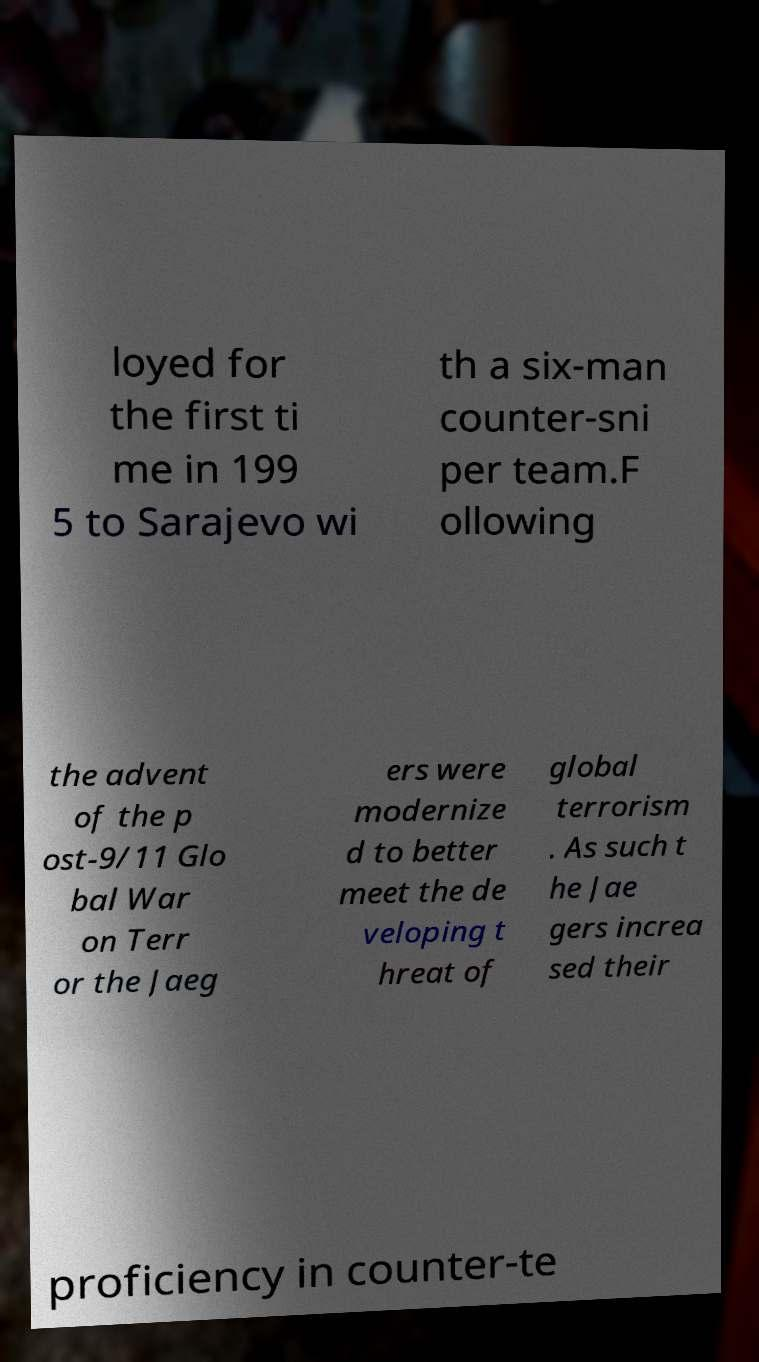There's text embedded in this image that I need extracted. Can you transcribe it verbatim? loyed for the first ti me in 199 5 to Sarajevo wi th a six-man counter-sni per team.F ollowing the advent of the p ost-9/11 Glo bal War on Terr or the Jaeg ers were modernize d to better meet the de veloping t hreat of global terrorism . As such t he Jae gers increa sed their proficiency in counter-te 